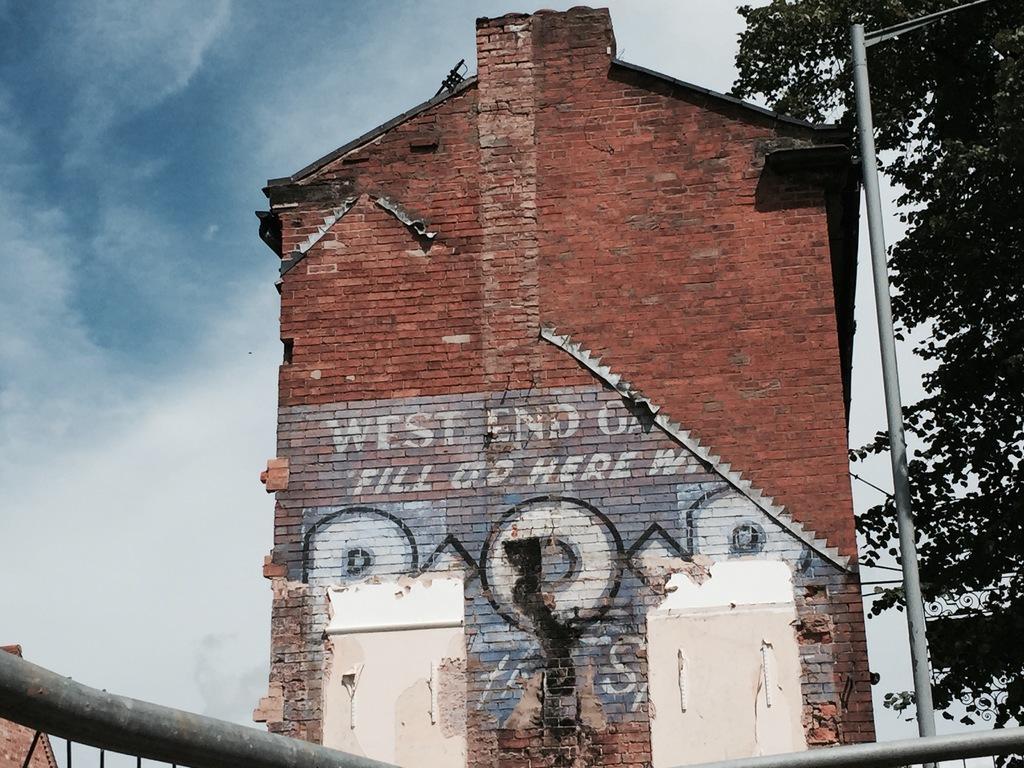Please provide a concise description of this image. In this image I can see few buildings, trees, poles and the sky. 